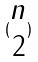<formula> <loc_0><loc_0><loc_500><loc_500>( \begin{matrix} n \\ 2 \end{matrix} )</formula> 